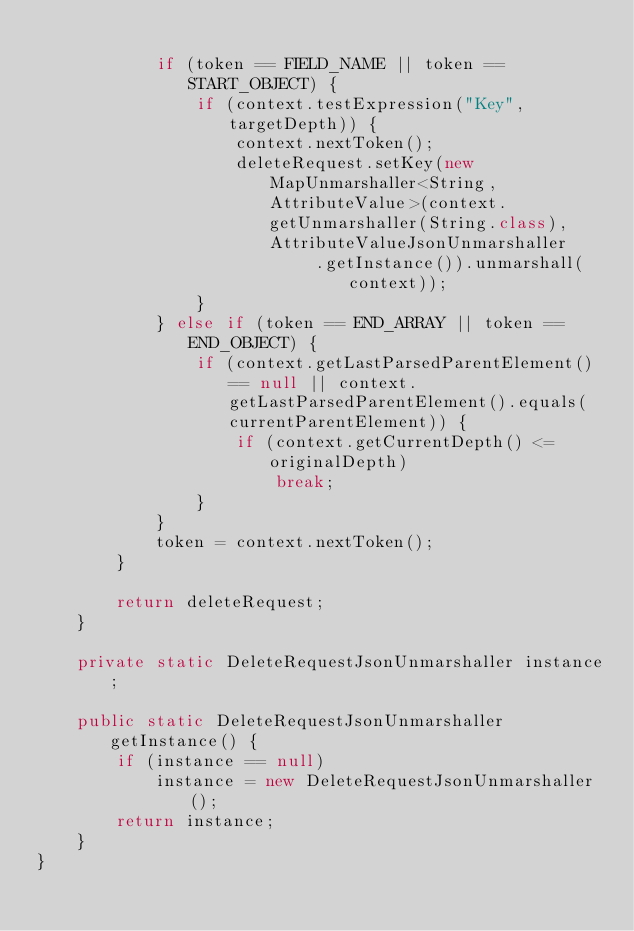Convert code to text. <code><loc_0><loc_0><loc_500><loc_500><_Java_>
            if (token == FIELD_NAME || token == START_OBJECT) {
                if (context.testExpression("Key", targetDepth)) {
                    context.nextToken();
                    deleteRequest.setKey(new MapUnmarshaller<String, AttributeValue>(context.getUnmarshaller(String.class), AttributeValueJsonUnmarshaller
                            .getInstance()).unmarshall(context));
                }
            } else if (token == END_ARRAY || token == END_OBJECT) {
                if (context.getLastParsedParentElement() == null || context.getLastParsedParentElement().equals(currentParentElement)) {
                    if (context.getCurrentDepth() <= originalDepth)
                        break;
                }
            }
            token = context.nextToken();
        }

        return deleteRequest;
    }

    private static DeleteRequestJsonUnmarshaller instance;

    public static DeleteRequestJsonUnmarshaller getInstance() {
        if (instance == null)
            instance = new DeleteRequestJsonUnmarshaller();
        return instance;
    }
}
</code> 